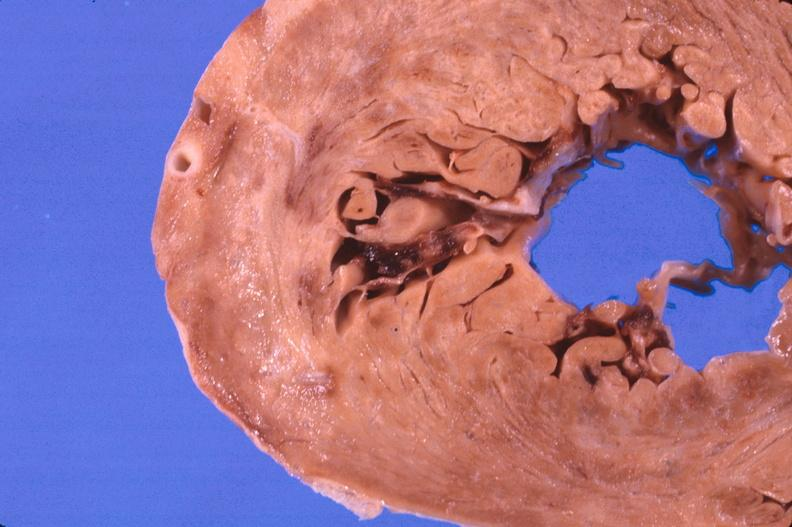what is present?
Answer the question using a single word or phrase. Cardiovascular 